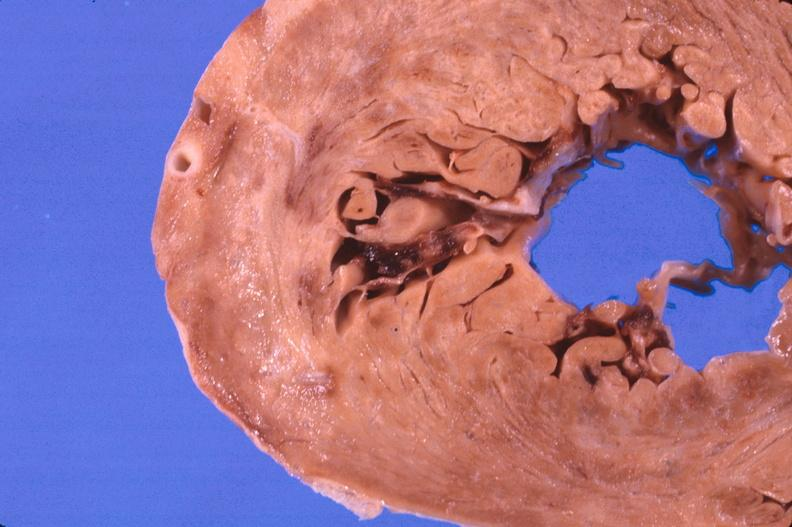what is present?
Answer the question using a single word or phrase. Cardiovascular 